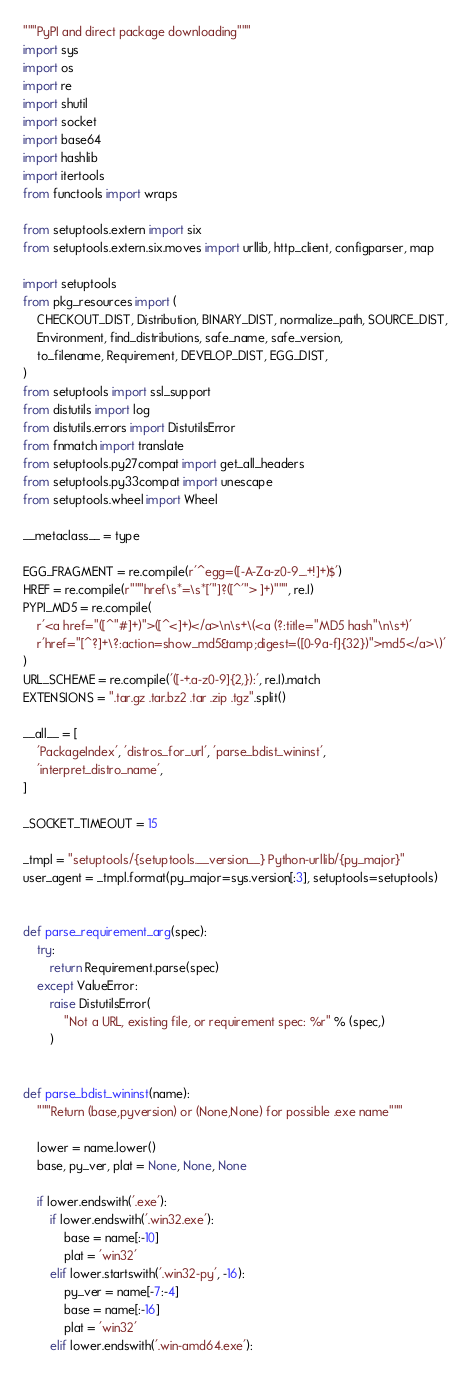<code> <loc_0><loc_0><loc_500><loc_500><_Python_>"""PyPI and direct package downloading"""
import sys
import os
import re
import shutil
import socket
import base64
import hashlib
import itertools
from functools import wraps

from setuptools.extern import six
from setuptools.extern.six.moves import urllib, http_client, configparser, map

import setuptools
from pkg_resources import (
    CHECKOUT_DIST, Distribution, BINARY_DIST, normalize_path, SOURCE_DIST,
    Environment, find_distributions, safe_name, safe_version,
    to_filename, Requirement, DEVELOP_DIST, EGG_DIST,
)
from setuptools import ssl_support
from distutils import log
from distutils.errors import DistutilsError
from fnmatch import translate
from setuptools.py27compat import get_all_headers
from setuptools.py33compat import unescape
from setuptools.wheel import Wheel

__metaclass__ = type

EGG_FRAGMENT = re.compile(r'^egg=([-A-Za-z0-9_.+!]+)$')
HREF = re.compile(r"""href\s*=\s*['"]?([^'"> ]+)""", re.I)
PYPI_MD5 = re.compile(
    r'<a href="([^"#]+)">([^<]+)</a>\n\s+\(<a (?:title="MD5 hash"\n\s+)'
    r'href="[^?]+\?:action=show_md5&amp;digest=([0-9a-f]{32})">md5</a>\)'
)
URL_SCHEME = re.compile('([-+.a-z0-9]{2,}):', re.I).match
EXTENSIONS = ".tar.gz .tar.bz2 .tar .zip .tgz".split()

__all__ = [
    'PackageIndex', 'distros_for_url', 'parse_bdist_wininst',
    'interpret_distro_name',
]

_SOCKET_TIMEOUT = 15

_tmpl = "setuptools/{setuptools.__version__} Python-urllib/{py_major}"
user_agent = _tmpl.format(py_major=sys.version[:3], setuptools=setuptools)


def parse_requirement_arg(spec):
    try:
        return Requirement.parse(spec)
    except ValueError:
        raise DistutilsError(
            "Not a URL, existing file, or requirement spec: %r" % (spec,)
        )


def parse_bdist_wininst(name):
    """Return (base,pyversion) or (None,None) for possible .exe name"""

    lower = name.lower()
    base, py_ver, plat = None, None, None

    if lower.endswith('.exe'):
        if lower.endswith('.win32.exe'):
            base = name[:-10]
            plat = 'win32'
        elif lower.startswith('.win32-py', -16):
            py_ver = name[-7:-4]
            base = name[:-16]
            plat = 'win32'
        elif lower.endswith('.win-amd64.exe'):</code> 